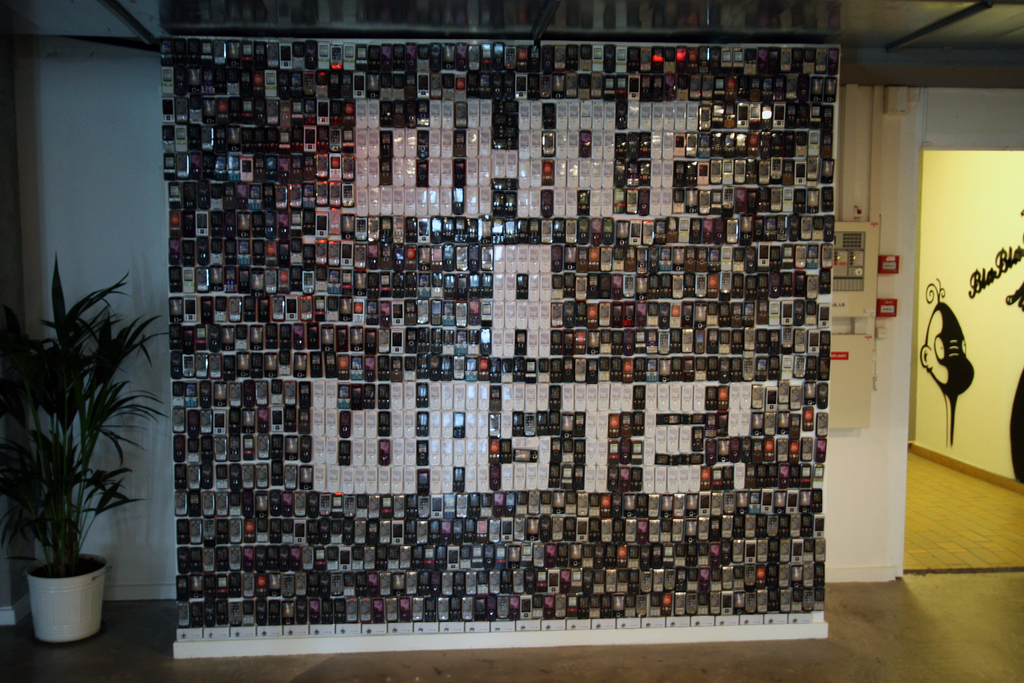Explain the visual content of the image in great detail. The image captures a unique wall installation situated in a gallery space. This installation is a composition of numerous small black and white photographs, meticulously arranged to form the silhouette of a large bird. The bird, seemingly in flight, adds a dynamic element to the otherwise static space. In the background, a potted plant adds a touch of nature to the indoor setting, while a sign, perhaps providing information about the installation, is also visible. The image as a whole conveys the creative use of photography as a medium for producing larger, symbolic artwork. 